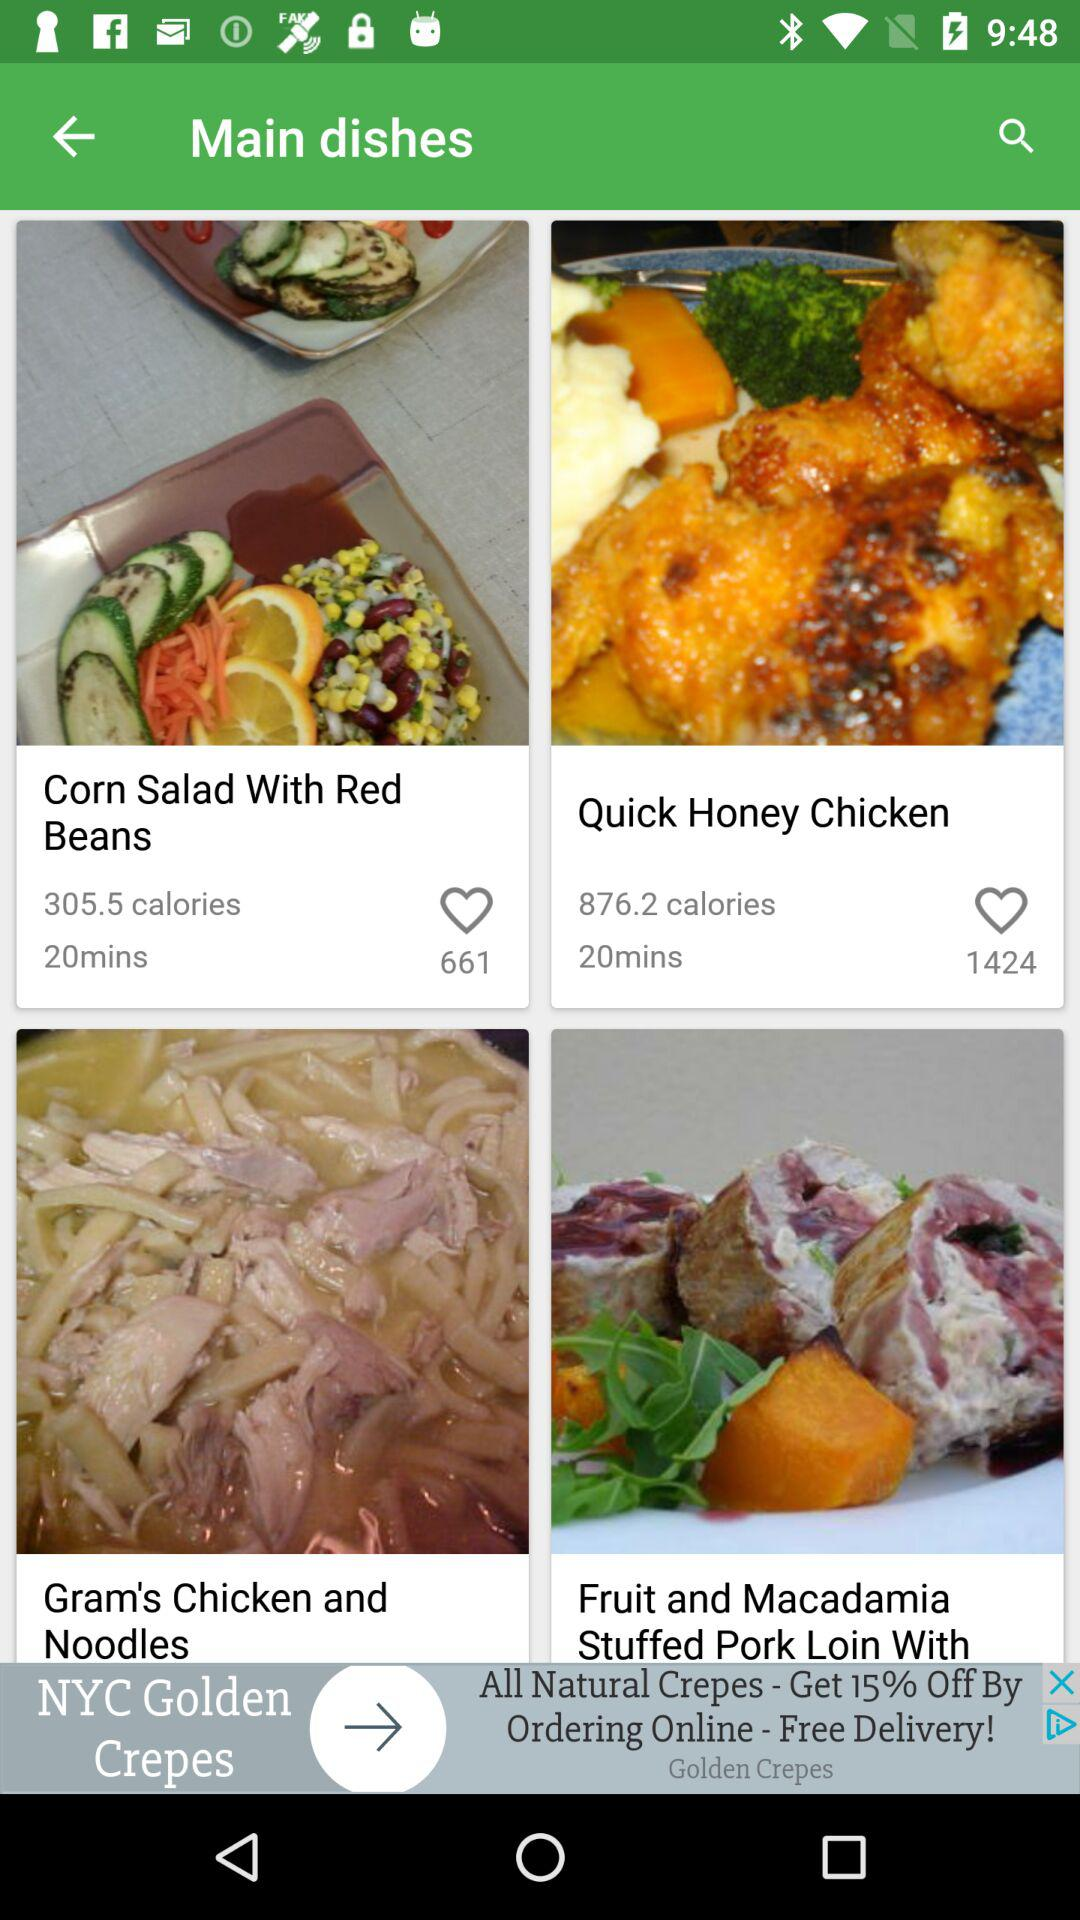What's the total number of likes of "Quick Honey Chicken" dish? The total number of likes is 1424. 